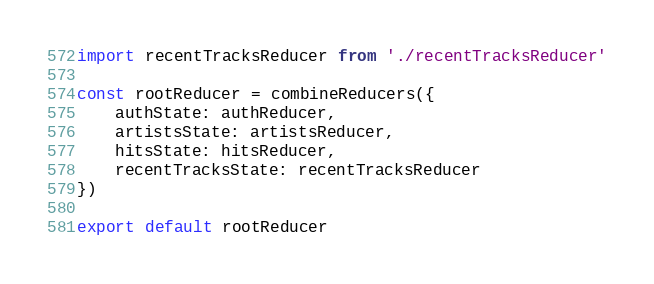Convert code to text. <code><loc_0><loc_0><loc_500><loc_500><_JavaScript_>import recentTracksReducer from './recentTracksReducer'

const rootReducer = combineReducers({
    authState: authReducer,
    artistsState: artistsReducer,
    hitsState: hitsReducer,
    recentTracksState: recentTracksReducer
})

export default rootReducer</code> 